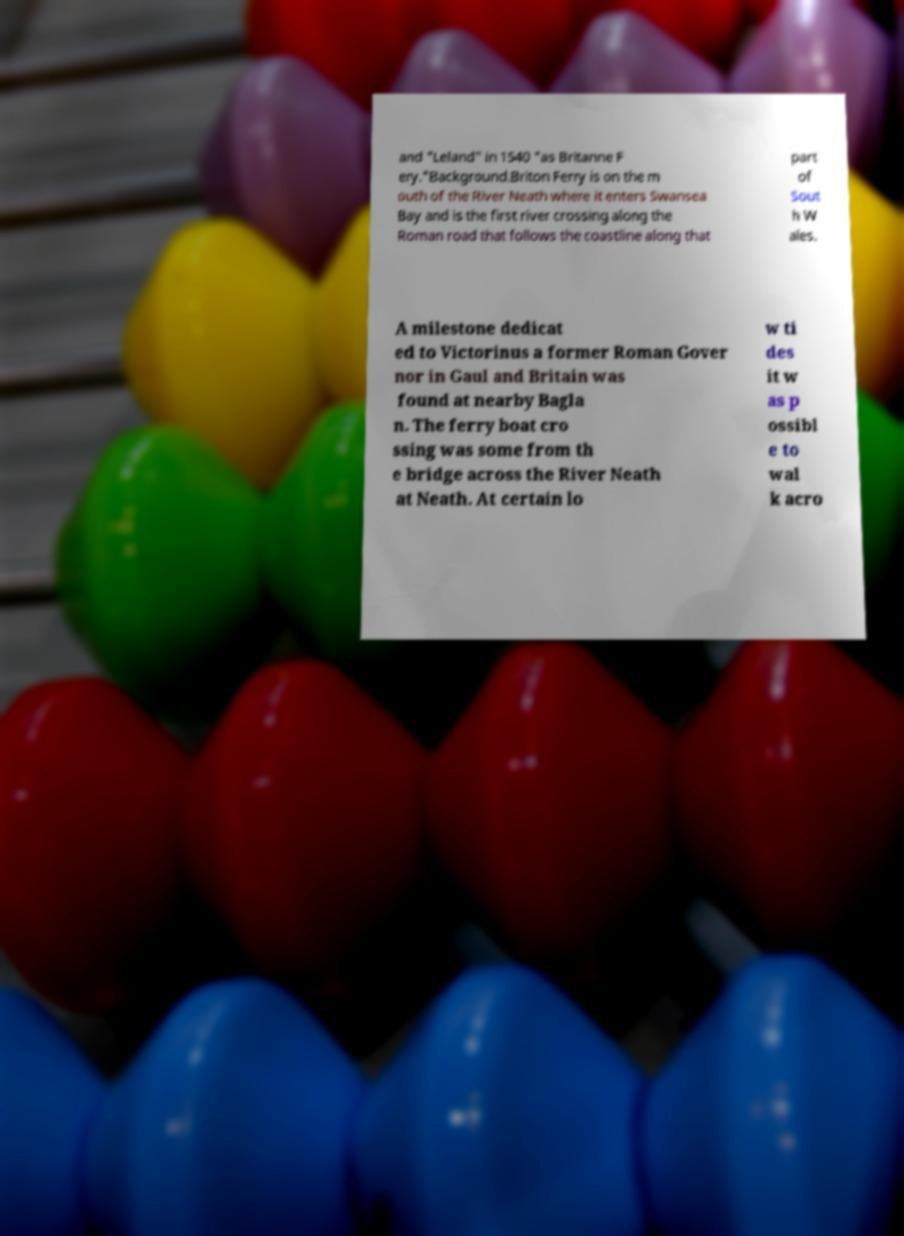Please read and relay the text visible in this image. What does it say? and "Leland" in 1540 "as Britanne F ery."Background.Briton Ferry is on the m outh of the River Neath where it enters Swansea Bay and is the first river crossing along the Roman road that follows the coastline along that part of Sout h W ales. A milestone dedicat ed to Victorinus a former Roman Gover nor in Gaul and Britain was found at nearby Bagla n. The ferry boat cro ssing was some from th e bridge across the River Neath at Neath. At certain lo w ti des it w as p ossibl e to wal k acro 